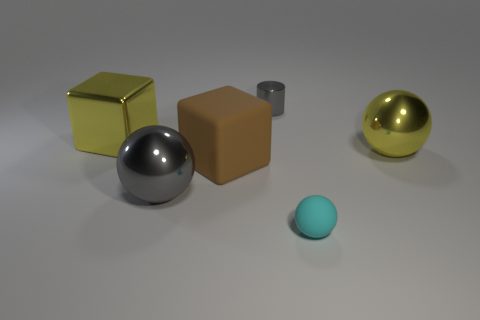There is a metallic object that is the same color as the cylinder; what size is it?
Your answer should be very brief. Large. There is a gray shiny object to the left of the small metallic cylinder; does it have the same shape as the brown matte object?
Offer a terse response. No. Are there more big cubes that are right of the big brown matte thing than big yellow metallic cubes right of the large gray metallic object?
Offer a terse response. No. There is a rubber thing behind the small cyan rubber ball; how many gray metallic spheres are on the right side of it?
Keep it short and to the point. 0. There is a big thing that is the same color as the tiny metallic thing; what is it made of?
Give a very brief answer. Metal. How many other things are there of the same color as the small cylinder?
Offer a terse response. 1. There is a big block behind the big ball that is on the right side of the tiny ball; what color is it?
Your response must be concise. Yellow. Is there a rubber sphere of the same color as the tiny rubber thing?
Provide a short and direct response. No. What number of metallic objects are big objects or yellow things?
Offer a very short reply. 3. Are there any other small objects made of the same material as the small cyan object?
Offer a terse response. No. 